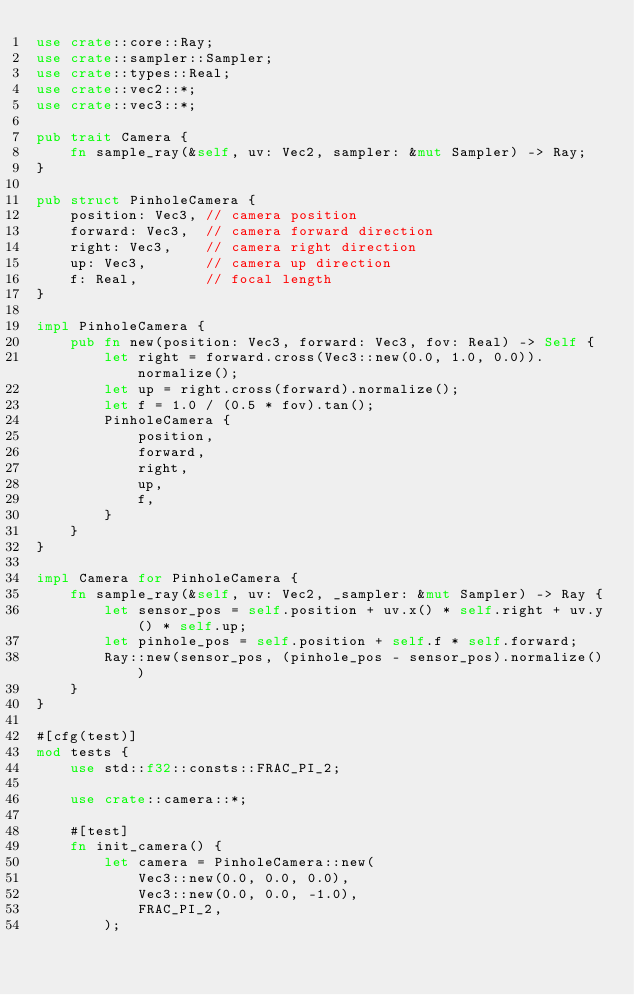<code> <loc_0><loc_0><loc_500><loc_500><_Rust_>use crate::core::Ray;
use crate::sampler::Sampler;
use crate::types::Real;
use crate::vec2::*;
use crate::vec3::*;

pub trait Camera {
    fn sample_ray(&self, uv: Vec2, sampler: &mut Sampler) -> Ray;
}

pub struct PinholeCamera {
    position: Vec3, // camera position
    forward: Vec3,  // camera forward direction
    right: Vec3,    // camera right direction
    up: Vec3,       // camera up direction
    f: Real,        // focal length
}

impl PinholeCamera {
    pub fn new(position: Vec3, forward: Vec3, fov: Real) -> Self {
        let right = forward.cross(Vec3::new(0.0, 1.0, 0.0)).normalize();
        let up = right.cross(forward).normalize();
        let f = 1.0 / (0.5 * fov).tan();
        PinholeCamera {
            position,
            forward,
            right,
            up,
            f,
        }
    }
}

impl Camera for PinholeCamera {
    fn sample_ray(&self, uv: Vec2, _sampler: &mut Sampler) -> Ray {
        let sensor_pos = self.position + uv.x() * self.right + uv.y() * self.up;
        let pinhole_pos = self.position + self.f * self.forward;
        Ray::new(sensor_pos, (pinhole_pos - sensor_pos).normalize())
    }
}

#[cfg(test)]
mod tests {
    use std::f32::consts::FRAC_PI_2;

    use crate::camera::*;

    #[test]
    fn init_camera() {
        let camera = PinholeCamera::new(
            Vec3::new(0.0, 0.0, 0.0),
            Vec3::new(0.0, 0.0, -1.0),
            FRAC_PI_2,
        );</code> 